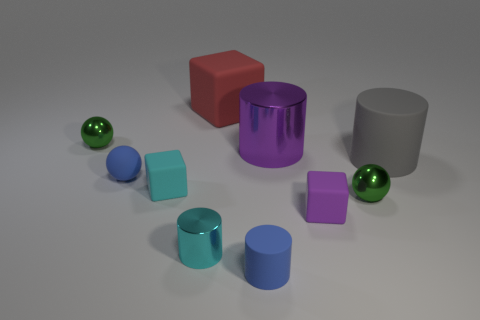Subtract all spheres. How many objects are left? 7 Add 6 purple matte things. How many purple matte things are left? 7 Add 6 blocks. How many blocks exist? 9 Subtract 0 brown spheres. How many objects are left? 10 Subtract all cyan cylinders. Subtract all blue metallic objects. How many objects are left? 9 